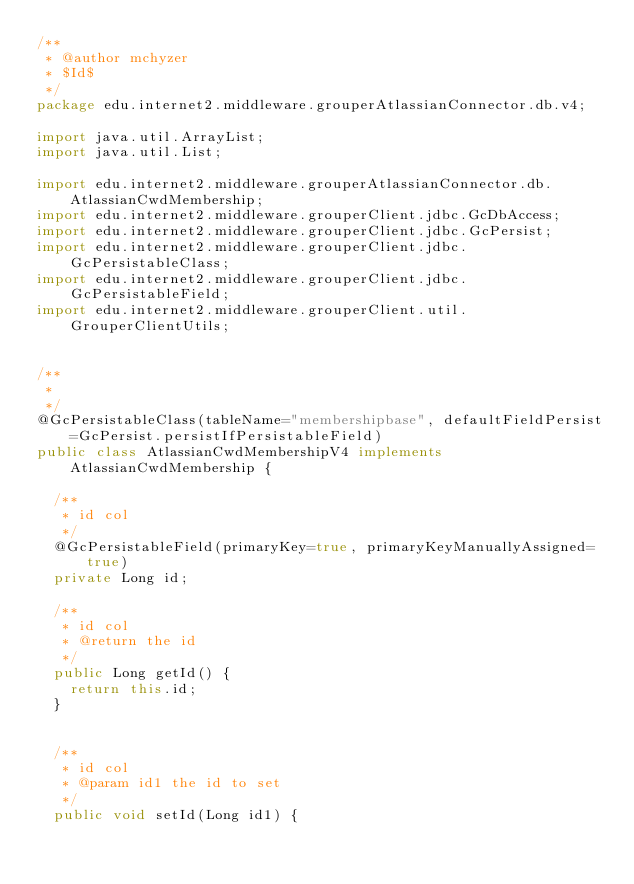Convert code to text. <code><loc_0><loc_0><loc_500><loc_500><_Java_>/**
 * @author mchyzer
 * $Id$
 */
package edu.internet2.middleware.grouperAtlassianConnector.db.v4;

import java.util.ArrayList;
import java.util.List;

import edu.internet2.middleware.grouperAtlassianConnector.db.AtlassianCwdMembership;
import edu.internet2.middleware.grouperClient.jdbc.GcDbAccess;
import edu.internet2.middleware.grouperClient.jdbc.GcPersist;
import edu.internet2.middleware.grouperClient.jdbc.GcPersistableClass;
import edu.internet2.middleware.grouperClient.jdbc.GcPersistableField;
import edu.internet2.middleware.grouperClient.util.GrouperClientUtils;


/**
 *
 */
@GcPersistableClass(tableName="membershipbase", defaultFieldPersist=GcPersist.persistIfPersistableField)
public class AtlassianCwdMembershipV4 implements AtlassianCwdMembership {

  /**
   * id col
   */
  @GcPersistableField(primaryKey=true, primaryKeyManuallyAssigned=true)
  private Long id;
  
  /**
   * id col
   * @return the id
   */
  public Long getId() {
    return this.id;
  }

  
  /**
   * id col
   * @param id1 the id to set
   */
  public void setId(Long id1) {</code> 